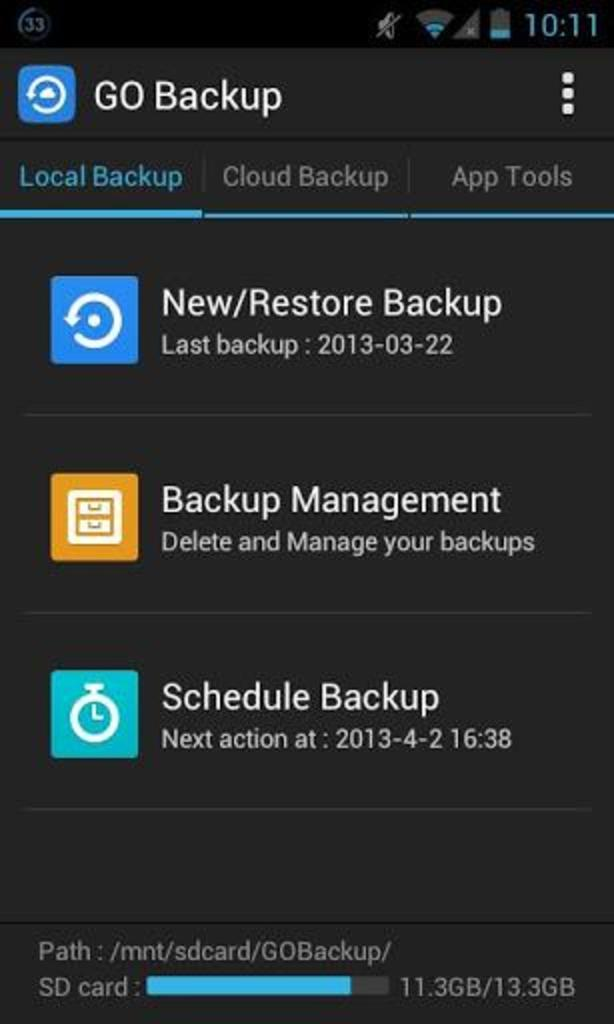<image>
Describe the image concisely. A screen shows restore, backup, and scheduling options. 